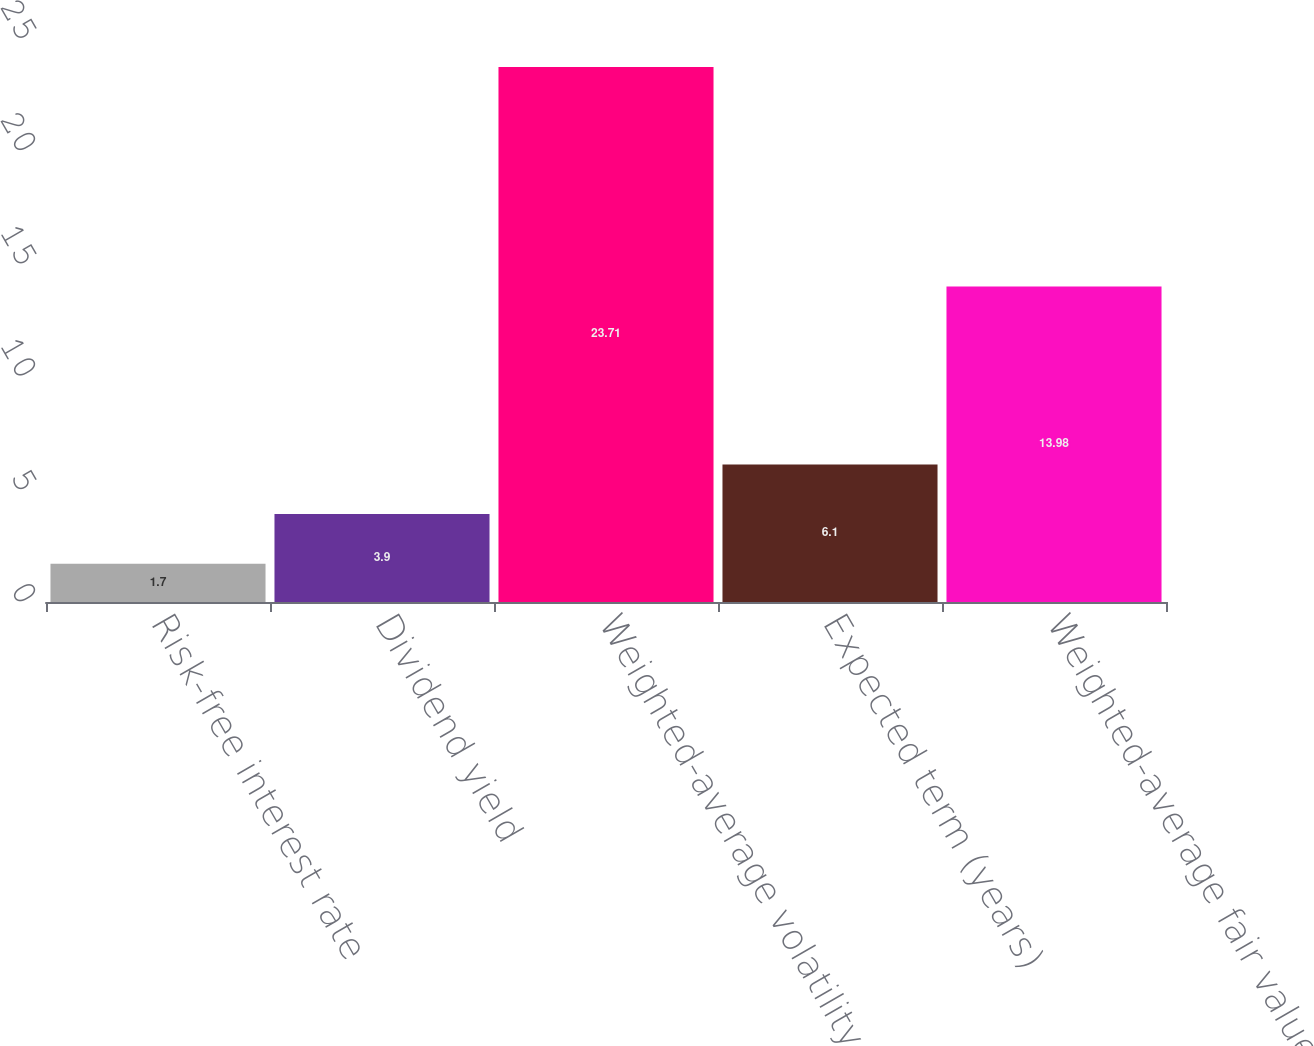Convert chart. <chart><loc_0><loc_0><loc_500><loc_500><bar_chart><fcel>Risk-free interest rate<fcel>Dividend yield<fcel>Weighted-average volatility<fcel>Expected term (years)<fcel>Weighted-average fair value<nl><fcel>1.7<fcel>3.9<fcel>23.71<fcel>6.1<fcel>13.98<nl></chart> 